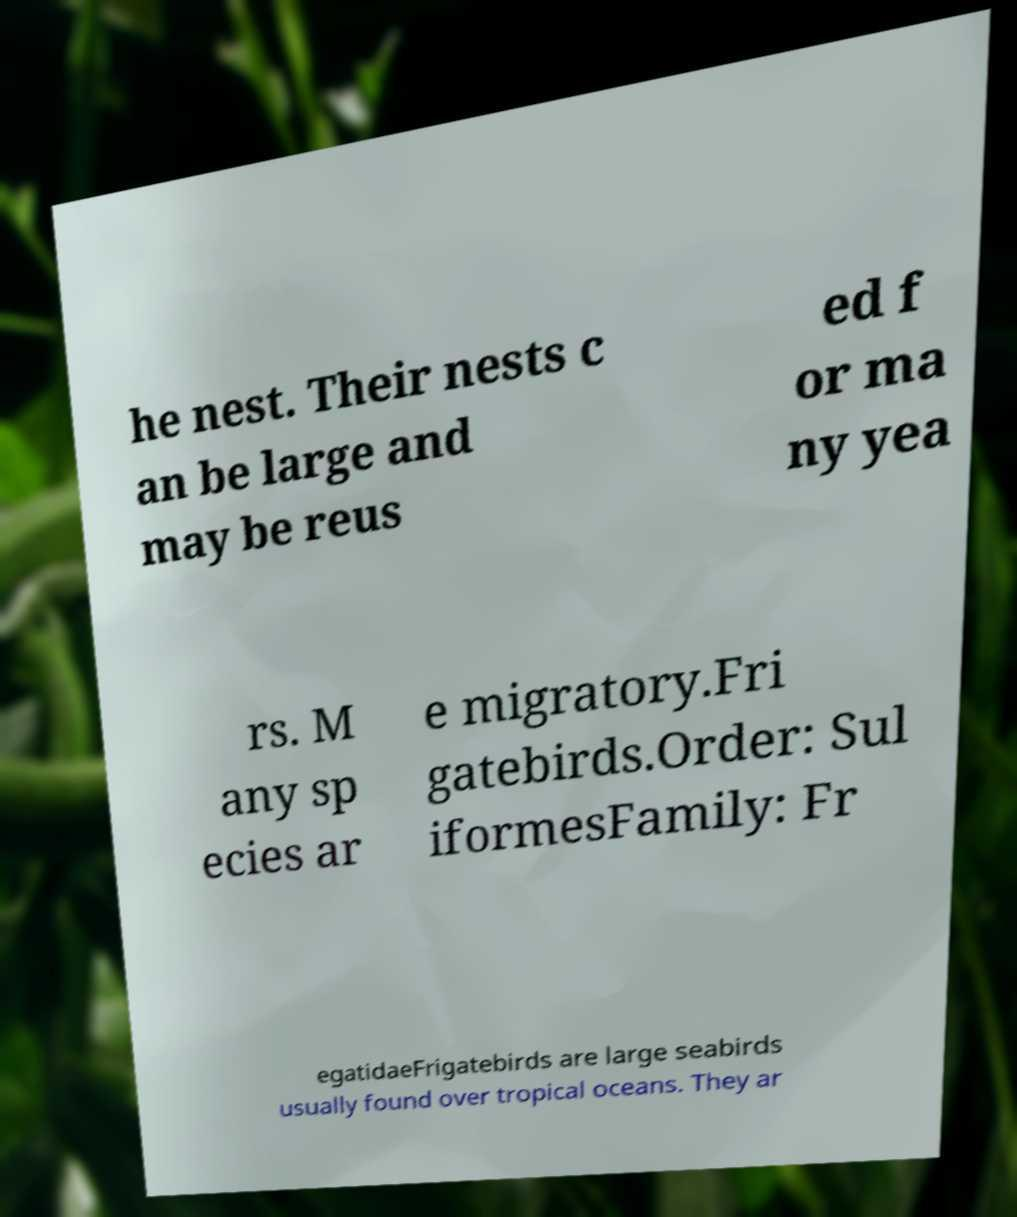For documentation purposes, I need the text within this image transcribed. Could you provide that? he nest. Their nests c an be large and may be reus ed f or ma ny yea rs. M any sp ecies ar e migratory.Fri gatebirds.Order: Sul iformesFamily: Fr egatidaeFrigatebirds are large seabirds usually found over tropical oceans. They ar 